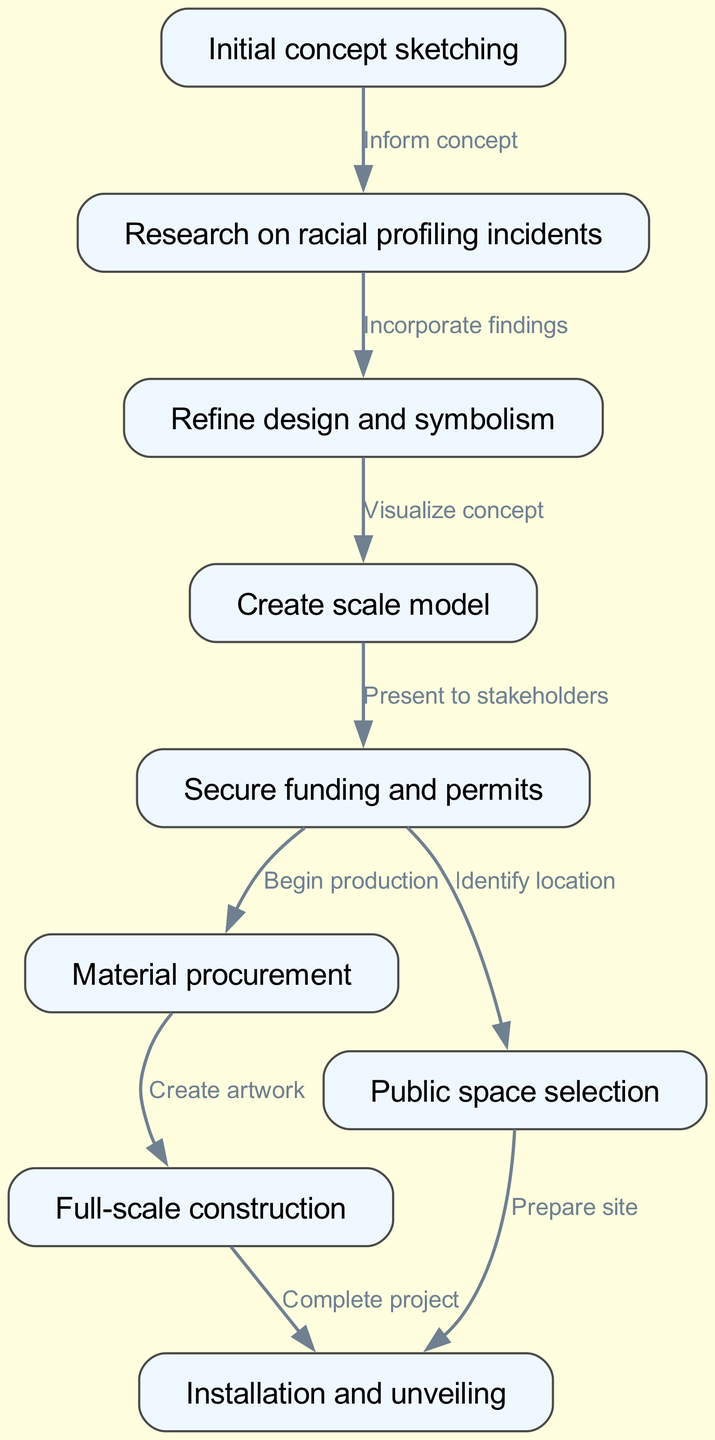What is the first step in the art piece journey? The diagram indicates that the first step is "Initial concept sketching," which is the starting point of the process.
Answer: Initial concept sketching How many nodes are in the diagram? By counting the defined nodes in the data, there are a total of nine nodes, which represent different steps in the journey of the art piece.
Answer: Nine What comes after "Research on racial profiling incidents"? The flow chart shows that "Refine design and symbolism" follows directly after "Research on racial profiling incidents," creating a sequential relationship.
Answer: Refine design and symbolism What type of activity is "Secure funding and permits"? The diagram describes "Secure funding and permits" as a step that is a necessary part of the overall production process, indicating it is an administrative activity.
Answer: Administrative Which two steps are connected by the edge labeled "Incorporate findings"? The edge labeled "Incorporate findings" connects "Research on racial profiling incidents" and "Refine design and symbolism," indicating that findings from research are incorporated into the design process.
Answer: Research on racial profiling incidents and Refine design and symbolism What is the last step before the installation? According to the flow of the diagram, the last step before installation is "Prepare site," which indicates readiness for the final unveiling.
Answer: Prepare site What step follows "Full-scale construction"? The diagram shows that after “Full-scale construction,” the next step is "Installation and unveiling," indicating that after construction is complete, the artwork is installed.
Answer: Installation and unveiling How many edges are in the diagram? The total number of edges is eight, which represents the connections between the various steps in the art piece's journey.
Answer: Eight What step is identified with the label "Begin production"? The label "Begin production" identifies the step "Material procurement" in the context of starting the physical creation of the artwork after securing funding.
Answer: Material procurement 